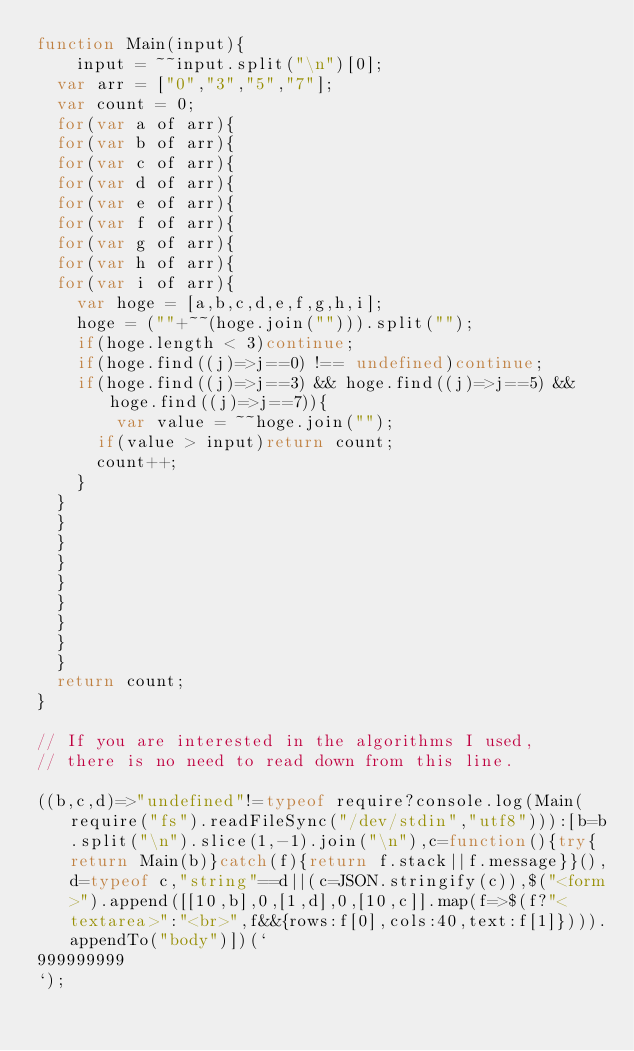<code> <loc_0><loc_0><loc_500><loc_500><_JavaScript_>function Main(input){
	input = ~~input.split("\n")[0];
  var arr = ["0","3","5","7"];
  var count = 0;
  for(var a of arr){
  for(var b of arr){
  for(var c of arr){
  for(var d of arr){
  for(var e of arr){
  for(var f of arr){
  for(var g of arr){
  for(var h of arr){
  for(var i of arr){
  	var hoge = [a,b,c,d,e,f,g,h,i];
    hoge = (""+~~(hoge.join(""))).split("");
    if(hoge.length < 3)continue;
    if(hoge.find((j)=>j==0) !== undefined)continue;
   	if(hoge.find((j)=>j==3) && hoge.find((j)=>j==5) && hoge.find((j)=>j==7)){
    	var value = ~~hoge.join("");
      if(value > input)return count;
      count++;
    }
  }
  }
  }
  }
  }
  }
  }
  }
  }
  return count;
}

// If you are interested in the algorithms I used, 
// there is no need to read down from this line.

((b,c,d)=>"undefined"!=typeof require?console.log(Main(require("fs").readFileSync("/dev/stdin","utf8"))):[b=b.split("\n").slice(1,-1).join("\n"),c=function(){try{return Main(b)}catch(f){return f.stack||f.message}}(),d=typeof c,"string"==d||(c=JSON.stringify(c)),$("<form>").append([[10,b],0,[1,d],0,[10,c]].map(f=>$(f?"<textarea>":"<br>",f&&{rows:f[0],cols:40,text:f[1]}))).appendTo("body")])(`
999999999
`);</code> 